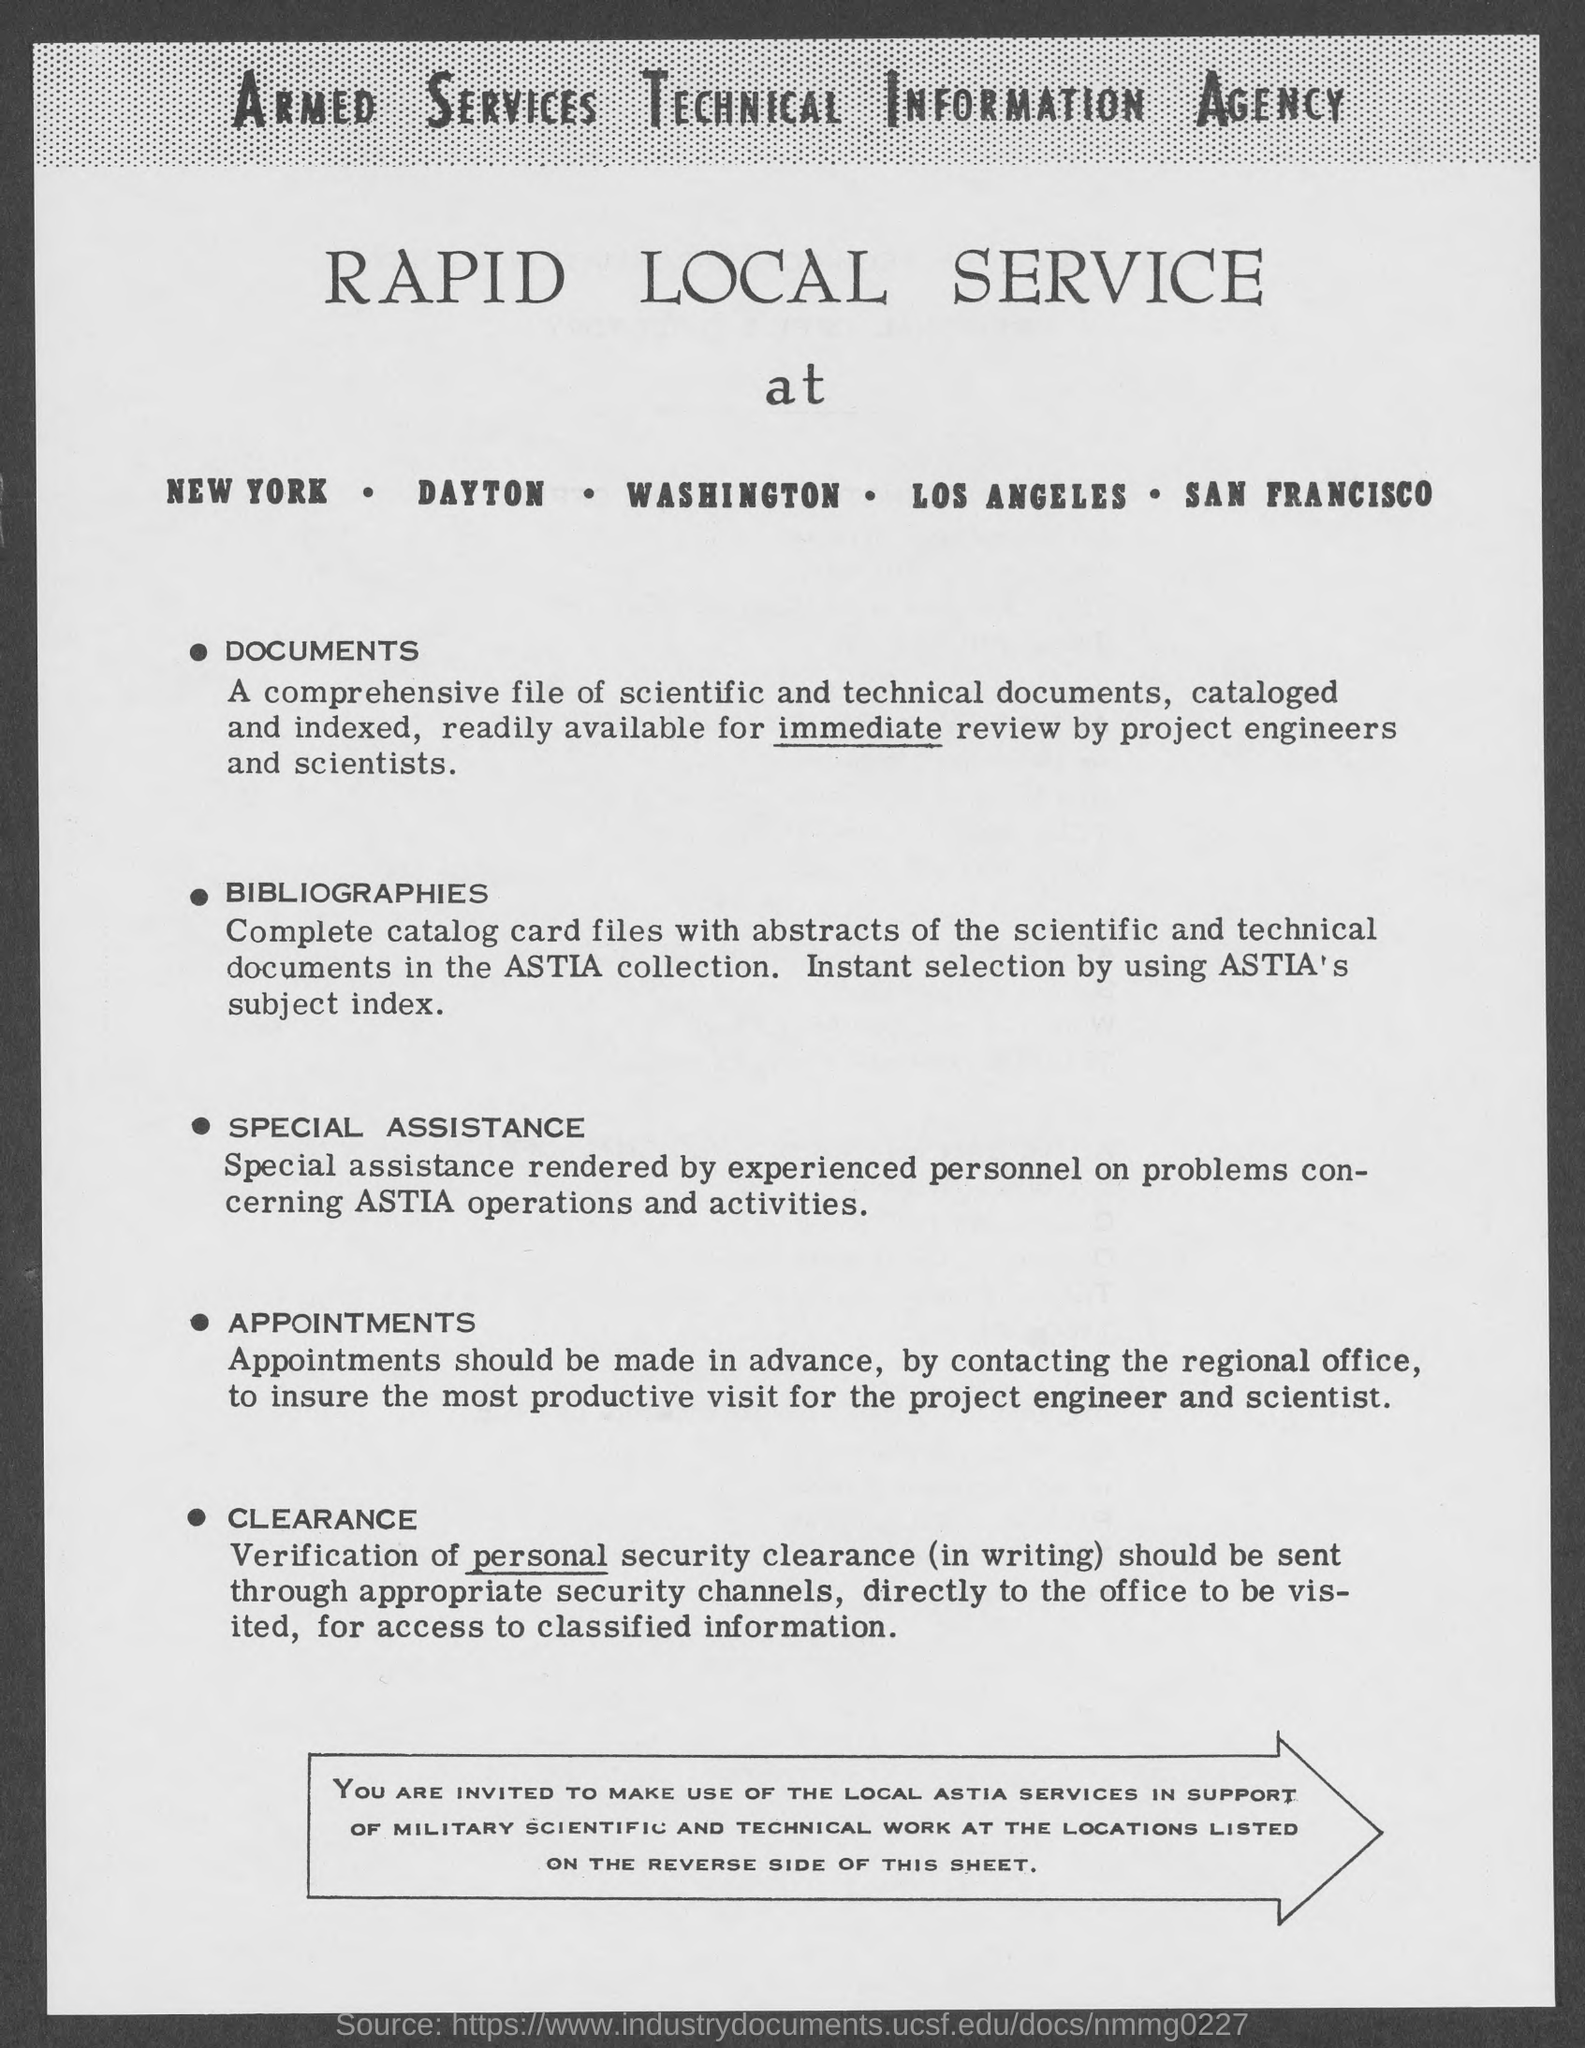What is the information agency ?
Your answer should be very brief. Armed Services Technical Information Agency. 